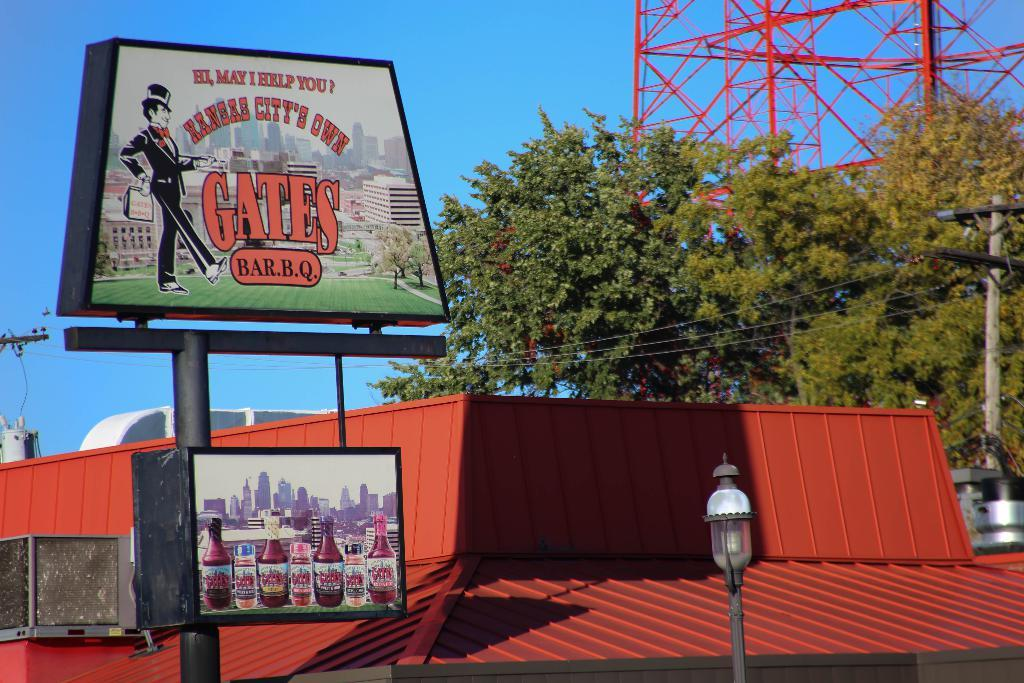<image>
Share a concise interpretation of the image provided. Sign in front of a building that says "GATES BBQ". 